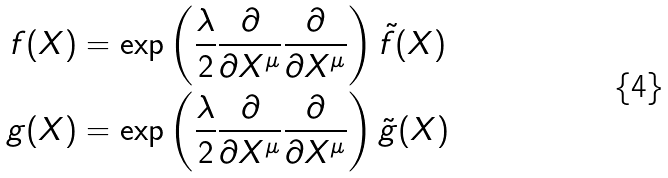<formula> <loc_0><loc_0><loc_500><loc_500>f ( X ) & = \exp \left ( \frac { \lambda } { 2 } \frac { \partial } { \partial X ^ { \mu } } \frac { \partial } { \partial X ^ { \mu } } \right ) \tilde { f } ( X ) \\ g ( X ) & = \exp \left ( \frac { \lambda } { 2 } \frac { \partial } { \partial X ^ { \mu } } \frac { \partial } { \partial X ^ { \mu } } \right ) \tilde { g } ( X )</formula> 